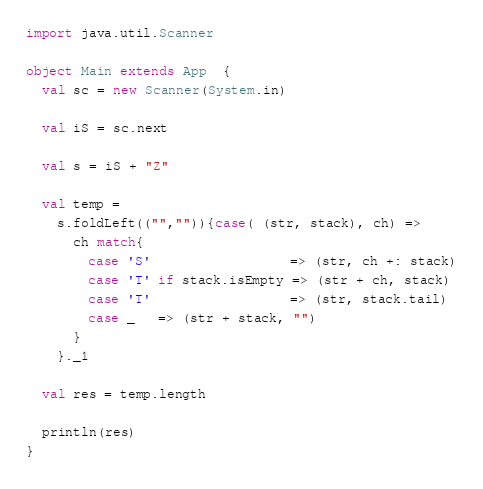<code> <loc_0><loc_0><loc_500><loc_500><_Scala_>import java.util.Scanner

object Main extends App  {
  val sc = new Scanner(System.in)

  val iS = sc.next

  val s = iS + "Z"

  val temp =
    s.foldLeft(("","")){case( (str, stack), ch) =>
      ch match{
        case 'S'                  => (str, ch +: stack)
        case 'T' if stack.isEmpty => (str + ch, stack)
        case 'T'                  => (str, stack.tail)
        case _   => (str + stack, "")
      }
    }._1

  val res = temp.length
  
  println(res)
}
</code> 